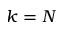Convert formula to latex. <formula><loc_0><loc_0><loc_500><loc_500>k = N</formula> 